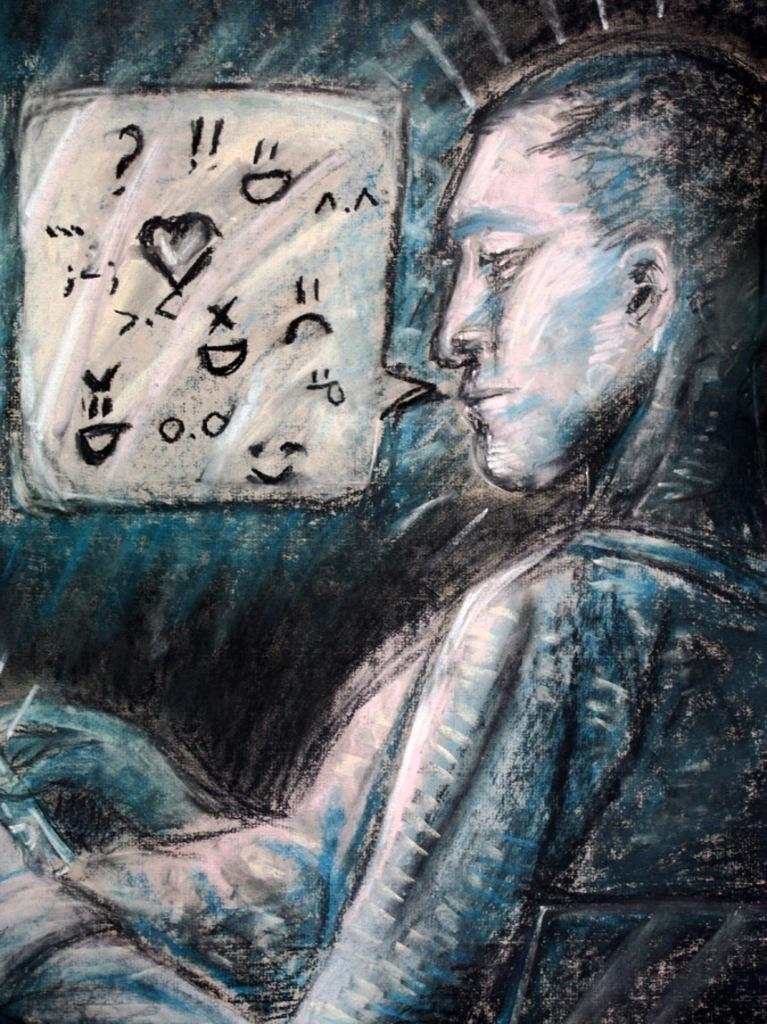What is the person in the image doing? The person is sitting on a chair in the image. Where is the person located in the image? The person is on the right side of the image. What feature is present in the image that suggests a conversation is taking place? There is a dialogue text box in the image. Where is the dialogue text box located in the image? The dialogue text box is on the top left of the image. How many trains are visible in the image? There are no trains present in the image. Is there a volcano erupting in the background of the image? There is no volcano present in the image. 